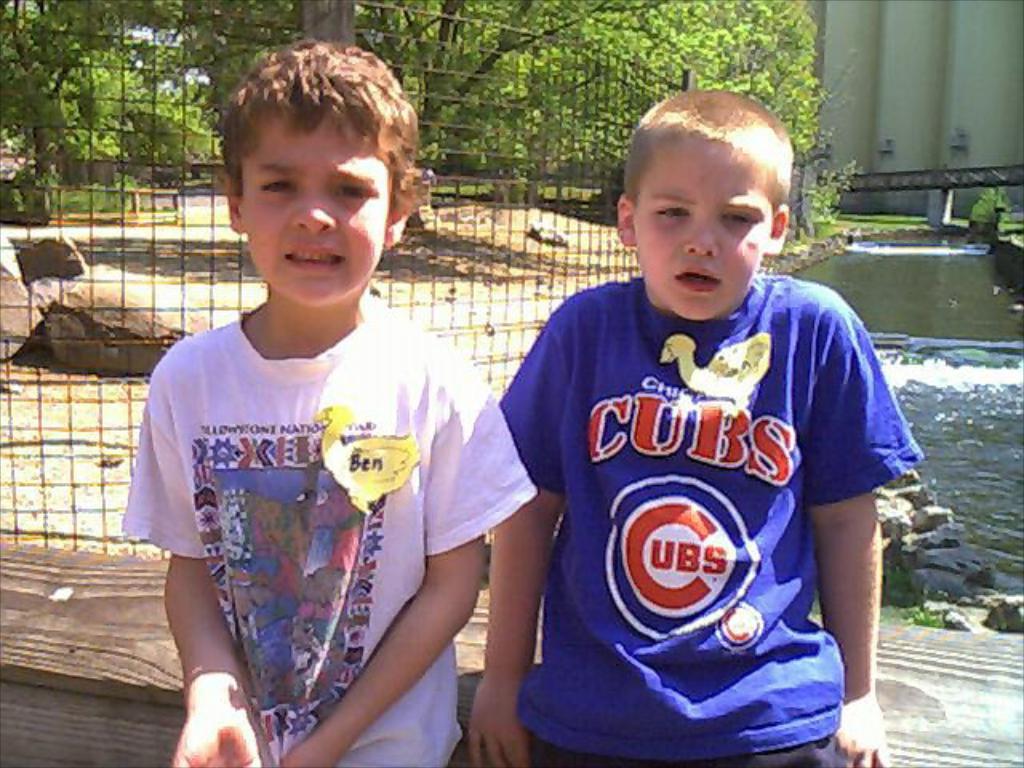What is the boy's name on the left?
Your answer should be very brief. Ben. 